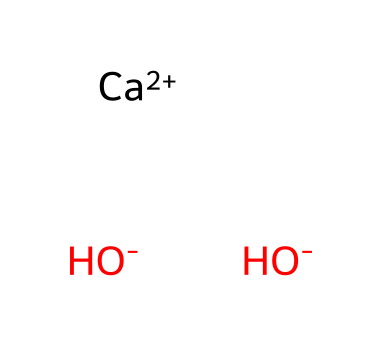How many hydroxide ions are present in calcium hydroxide? The chemical structure indicates the presence of two hydroxide ions, as represented by the two OH groups bonded to the calcium ion.
Answer: two What is the oxidation state of calcium in calcium hydroxide? In calcium hydroxide, calcium has an oxidation state of +2, which is indicated by the [Ca+2] notation in the SMILES.
Answer: +2 What is the name of the chemical represented by this structure? The chemical structure corresponds to calcium hydroxide, as deciphered from the components of the SMILES notation (calcium and hydroxide).
Answer: calcium hydroxide How many total atoms are present in calcium hydroxide? By analyzing the structure, there is one calcium atom and two hydroxide groups, each contributing one oxygen and one hydrogen atom, resulting in a total of five atoms (1 Ca + 2 O + 2 H).
Answer: five What type of chemical is calcium hydroxide classified as? Calcium hydroxide is classified as a base, typically due to its ability to accept protons and its hydroxide ion content ([OH-]).
Answer: base What is the charge of each hydroxide ion in the structure? The notation [OH-] reveals that each hydroxide ion carries a negative charge, confirming its anionic nature.
Answer: negative What role does calcium hydroxide play in water treatment processes? Calcium hydroxide is primarily used as a coagulant and a neutralizing agent in water treatment, helping to remove impurities and balance pH levels.
Answer: coagulant 